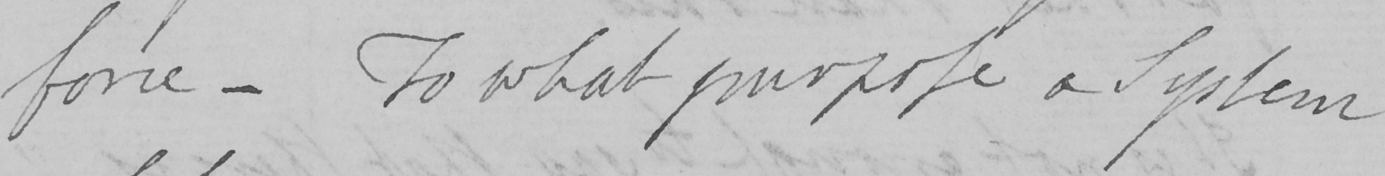Can you tell me what this handwritten text says? force  _  To what purpose a System 